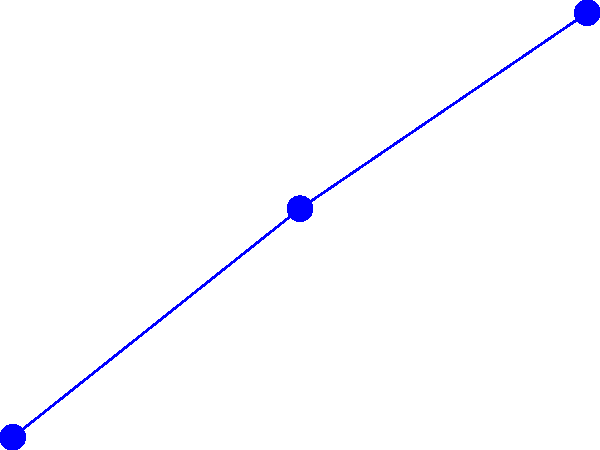As a community organizer in Washington, D.C., you're considering implementing wind turbines to promote sustainable energy. Based on the efficiency graph of different wind turbine designs, which type would you recommend for areas with average wind speeds of 2.5 m/s, and why? To answer this question, we need to analyze the efficiency of each turbine type at the given wind speed of 2.5 m/s. Let's break it down step-by-step:

1. Identify the turbine types:
   - Blue line with circles: Horizontal Axis Wind Turbine (HAWT)
   - Red line with crosses: Vertical Axis Wind Turbine (VAWT)
   - Green line with squares: Savonius Wind Turbine

2. Estimate efficiency at 2.5 m/s:
   - HAWT: Approximately 0.45
   - VAWT: Approximately 0.41
   - Savonius: Approximately 0.35

3. Compare efficiencies:
   The HAWT has the highest efficiency at 2.5 m/s, followed by the VAWT, and then the Savonius turbine.

4. Consider other factors:
   - HAWTs are generally more efficient but require more space and may have a larger visual impact.
   - VAWTs can be more suitable for urban environments due to their compact design and ability to handle turbulent winds.
   - Savonius turbines are simple and low-cost but less efficient.

5. Community context:
   As a community organizer in Washington, D.C., you need to consider:
   - Available space in urban areas
   - Visual impact on the cityscape
   - Noise concerns for residents
   - Cost-effectiveness and long-term benefits

Given these factors, the Vertical Axis Wind Turbine (VAWT) would be the most suitable recommendation. While slightly less efficient than the HAWT, it offers a good balance of efficiency and practicality for an urban setting like Washington, D.C. Its compact design makes it more adaptable to limited spaces, and it can handle the turbulent winds often found in cities.
Answer: Vertical Axis Wind Turbine (VAWT) 